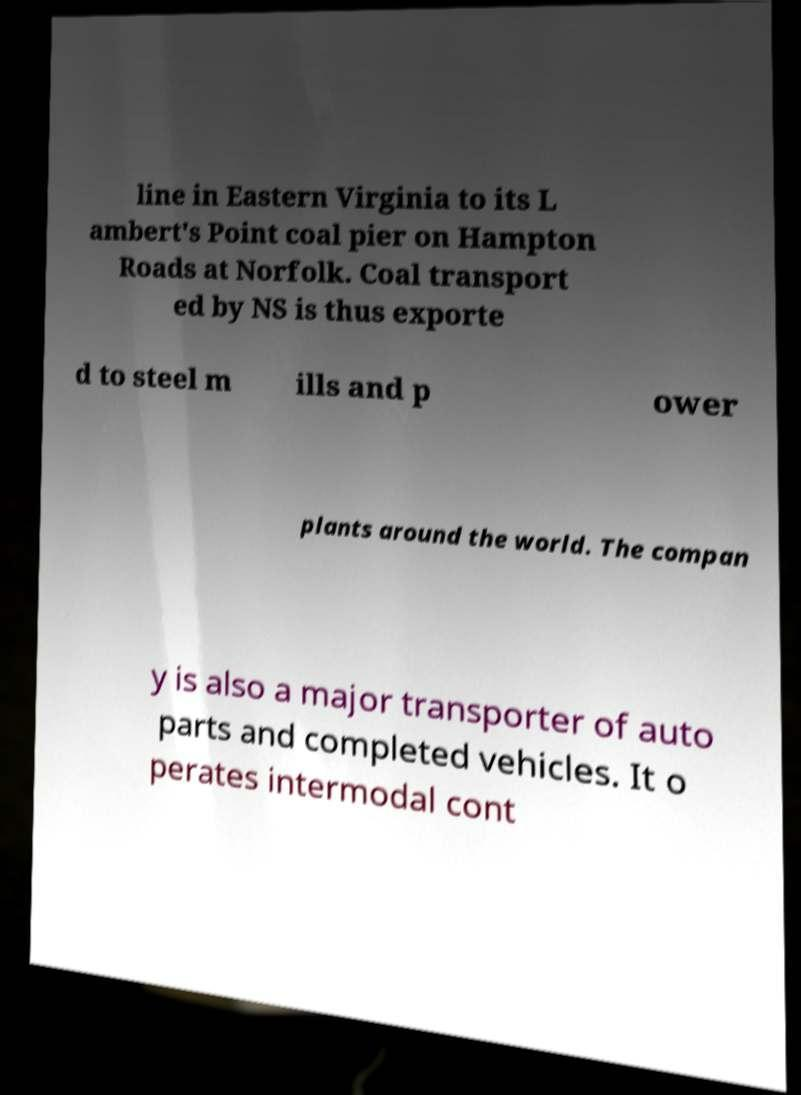I need the written content from this picture converted into text. Can you do that? line in Eastern Virginia to its L ambert's Point coal pier on Hampton Roads at Norfolk. Coal transport ed by NS is thus exporte d to steel m ills and p ower plants around the world. The compan y is also a major transporter of auto parts and completed vehicles. It o perates intermodal cont 